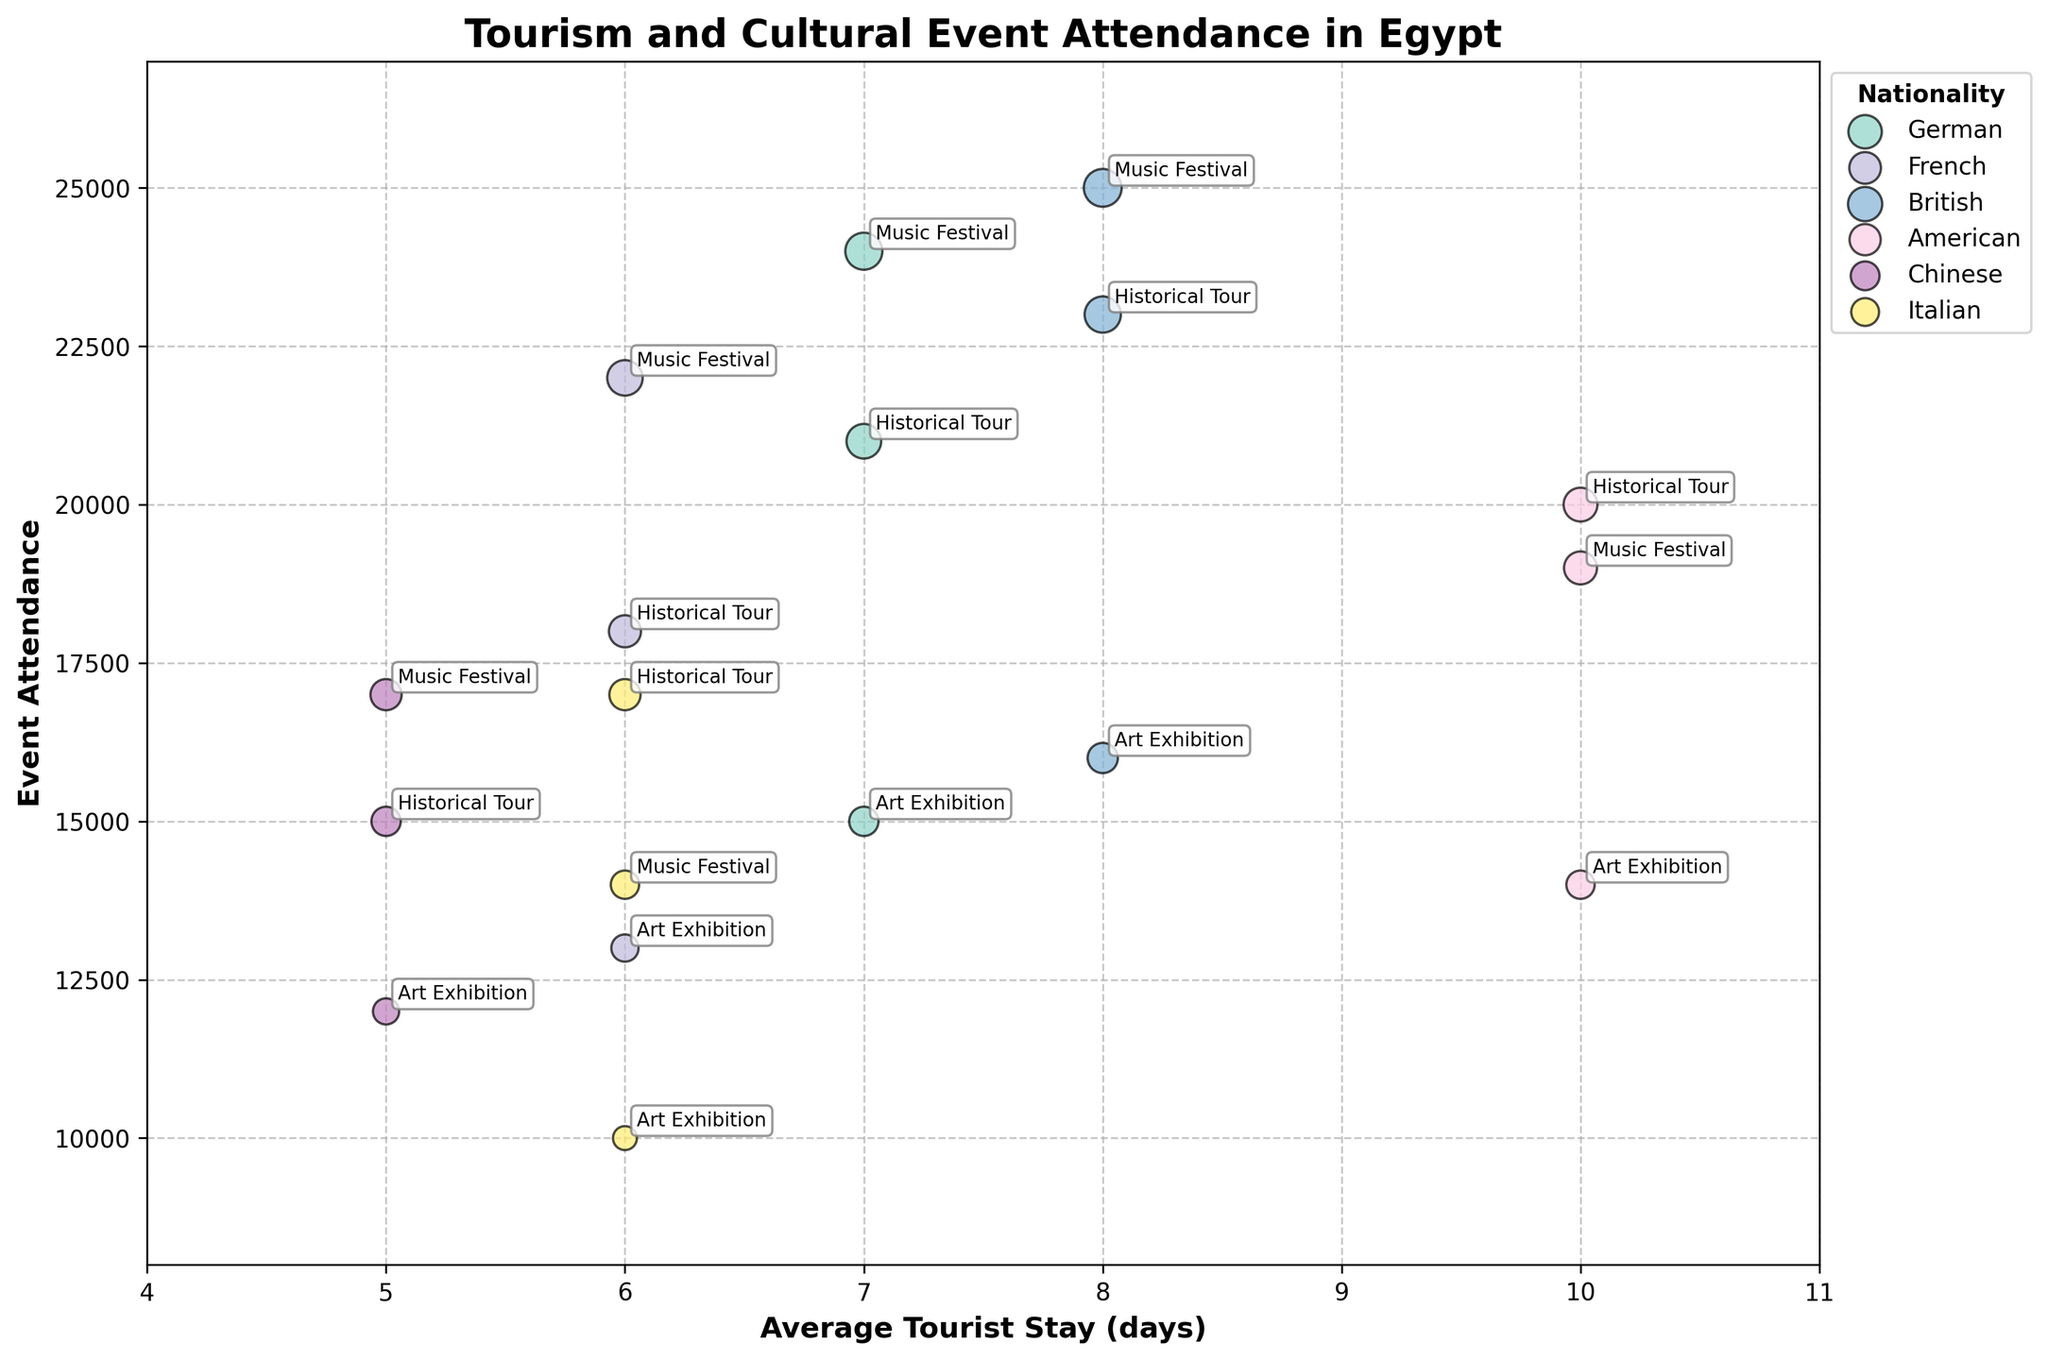Which nationality has the highest average tourist stay? By looking at the x-axis, we can see that Americans have an average tourist stay of 10 days, which is the highest among all nationalities.
Answer: Americans What is the title of the figure? The title of the figure is displayed prominently at the top.
Answer: Tourism and Cultural Event Attendance in Egypt How many different nationalities are represented in the figure? Each unique color represents a different nationality, and there are six different colors. They include German, French, British, American, Chinese, and Italian.
Answer: 6 Which event type has the highest attendance for the British nationality? By finding the bubbles corresponding to the British nationality and checking the y-axis values, the Music Festival has the highest attendance of 25,000.
Answer: Music Festival Among the nationalities plotted, which nationality has the smallest event attendance for Art Exhibitions? The data points for Art Exhibitions are labeled, and the Chinese nationality has the smallest attendance at 12,000 for this event type.
Answer: Chinese What is the average event attendance across all Italian events? The attendance for Italian events are 14,000 (Music Festival), 10,000 (Art Exhibition), and 17,000 (Historical Tour). The average is (14000 + 10000 + 17000) / 3 = 13,666.67.
Answer: 13,666.67 Which nationality has more attendance at Historical Tours compared to their Music Festival attendance? By comparing the bubbles labeled for Historical Tour and Music Festival, both German (21,000 > 24,000) and Italian (17,000 > 14,000) have lower attendance for Historical Tours compared to Music Festivals.
Answer: German What is the range of event attendance values shown in the figure? The minimum event attendance is for the Italian Art Exhibition (10,000), and the maximum is the British Music Festival (25,000). The range is 25,000 - 10,000 = 15,000.
Answer: 15,000 Is there any nationality for which the average tourist stay is less than 6 days but has an event attendance greater than 15,000? The Chinese nationality has an average tourist stay of 5 days and their event attendance for the Music Festival is 17,000.
Answer: Chinese 